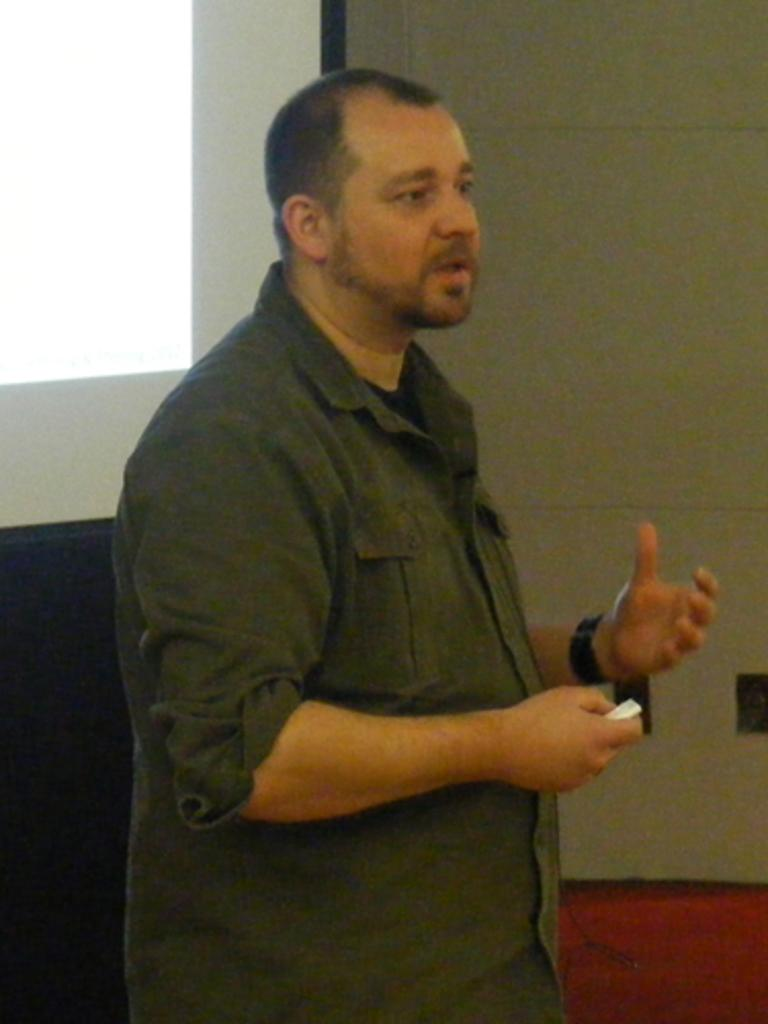What is present in the image? There is a man in the image. What is the man doing in the image? The man is holding an object. What can be seen in the background of the image? There is a wall and other objects visible in the background of the image. How many cows are visible in the image? There are no cows present in the image. What type of cheese is the man holding in the image? The man is not holding any cheese in the image. 